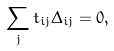Convert formula to latex. <formula><loc_0><loc_0><loc_500><loc_500>\sum _ { j } t _ { i j } \Delta _ { i j } = 0 ,</formula> 